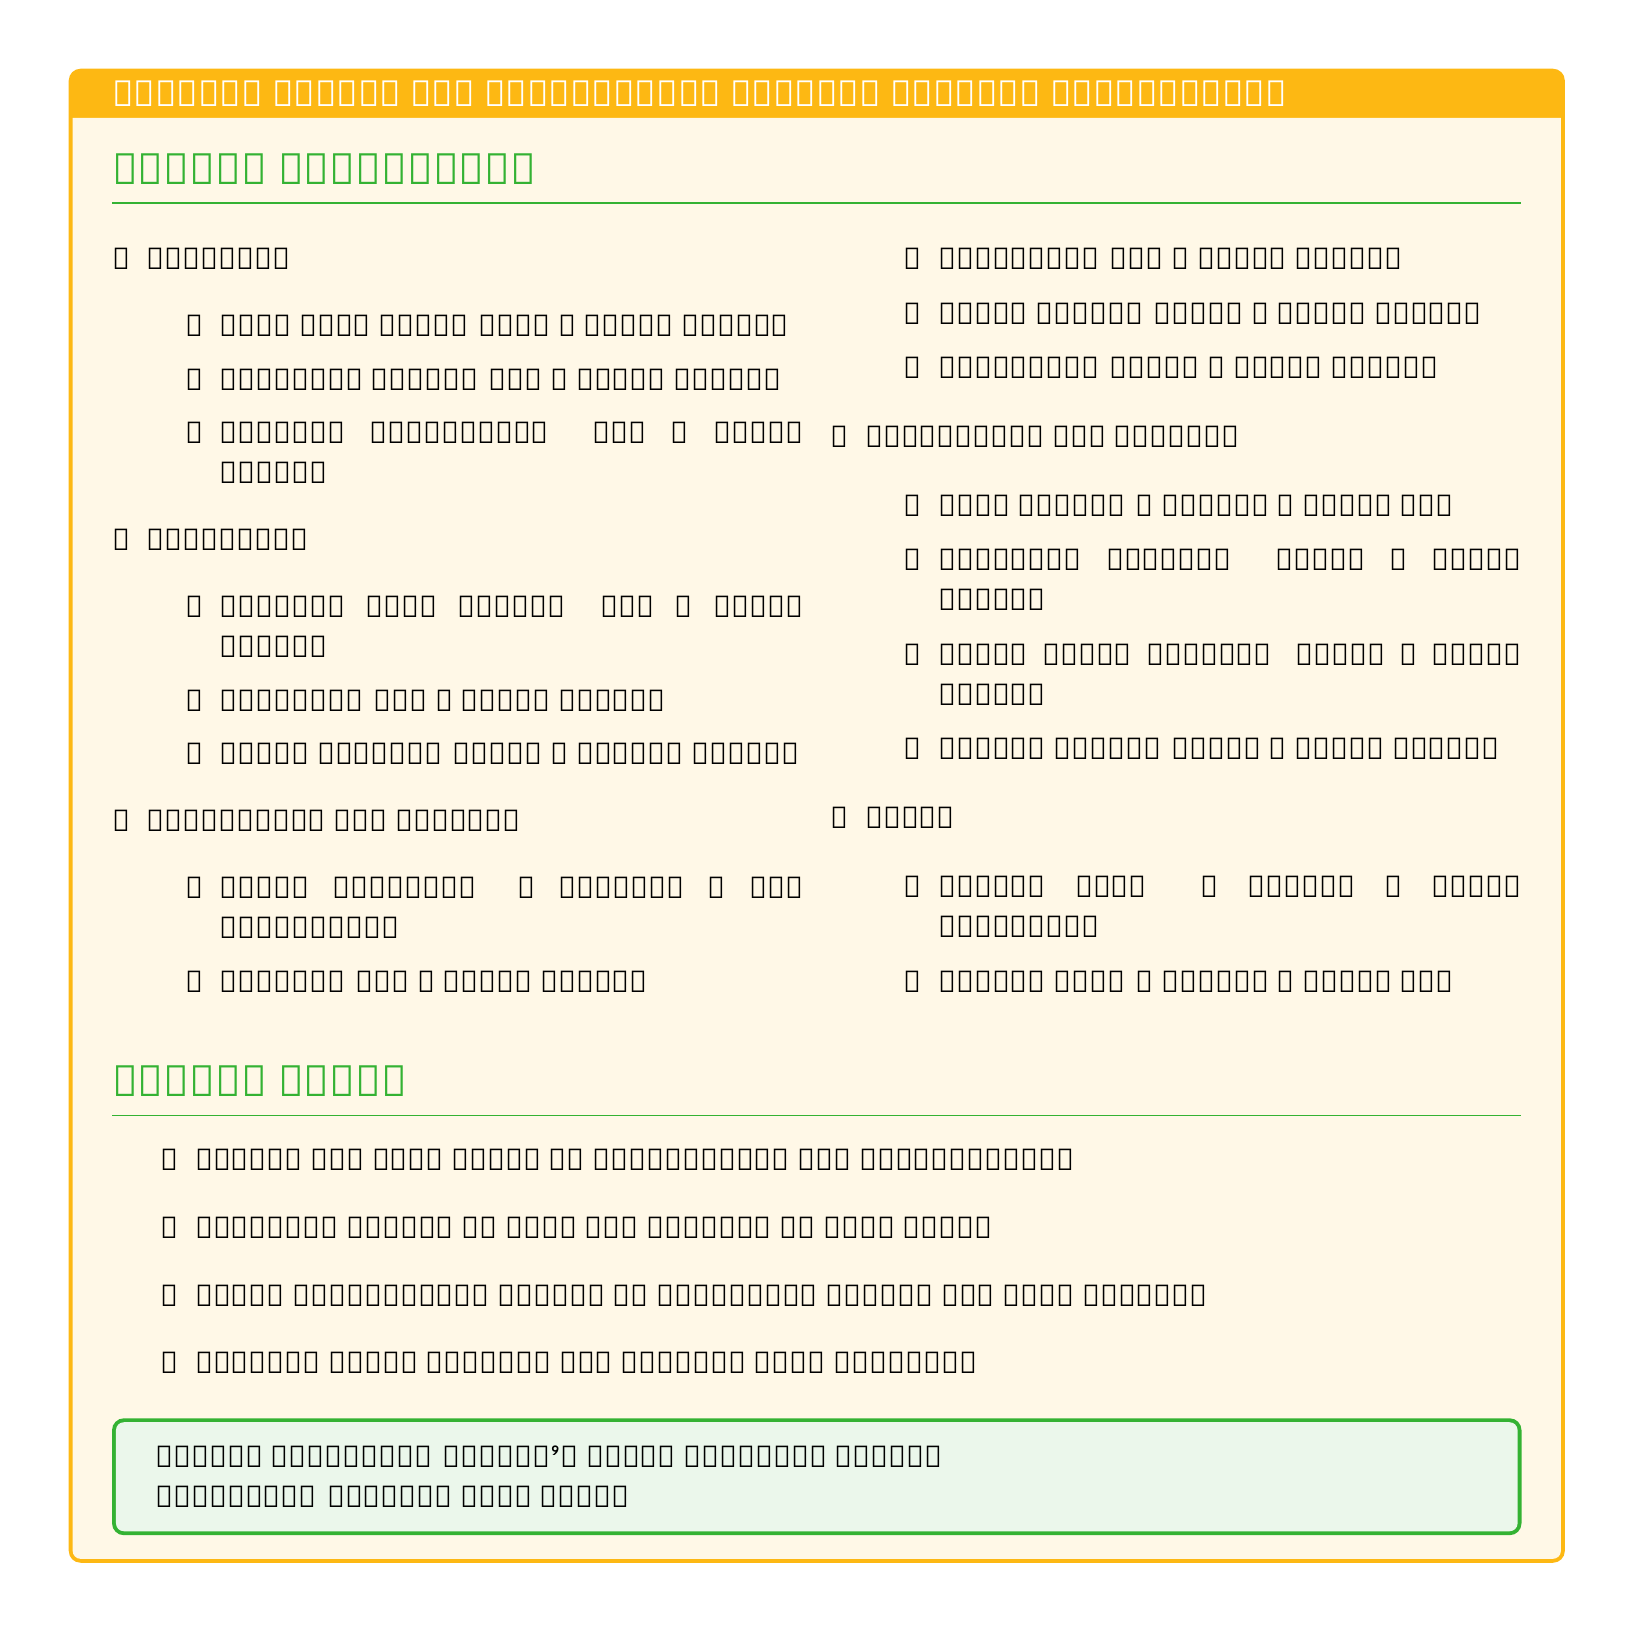What is the price per kilogram of rice? The price per kilogram of rice (Paw San) is specified in the staples section of the document as 2,500 MMK/kg.
Answer: 2,500 MMK/kg How many kilograms of catfish are included in the budget? The budget specifies the quantity of catfish (Nga Yant) to be included, which is mentioned in the protein section as 2kg.
Answer: 2kg What is the total amount spent on vegetables and fruits? To calculate the total for vegetables and fruits, we need to sum the individual prices from the listed items: (8 bundles of Water spinach at 500 MMK each) + (1kg Garlic at 3,000 MMK) + (1kg Shallots at 2,500 MMK) + (0.5kg Green chili at 2,000 MMK) + (0.5kg Tamarind at 3,000 MMK), which equals 15,500 MMK.
Answer: 15,500 MMK How much is the shrimp paste per kilogram? The price for shrimp paste is listed in the condiments and spices section at 4,000 MMK/kg for 0.5kg.
Answer: 4,000 MMK/kg What is the total budget allocated for oils? The total budget for oils includes the cost of 2 liters of peanut oil at 4,000 MMK/liter and 1 bottle of sesame oil at 3,500 MMK, totaling to 11,500 MMK.
Answer: 11,500 MMK Where is the market location mentioned for purchasing the ingredients? The document provides the market location for purchases as Yangon's Thiri Mingalar Market.
Answer: Thiri Mingalar Market How often should fresh ingredients be purchased? The notes in the document recommend purchasing fresh ingredients weekly for best quality.
Answer: Weekly What color is the box that contains budget notes? The budget notes section is contained within a box that uses a background color of myanmarGreen!10.
Answer: myanmarGreen!10 What is advised for saving money on staples? The budget notes indicate that buying in bulk for staples is a suggested way to save money.
Answer: Buying in bulk 